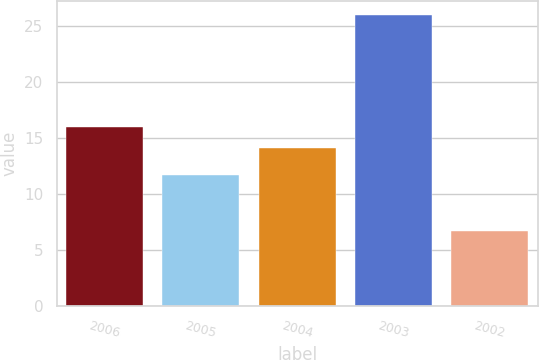<chart> <loc_0><loc_0><loc_500><loc_500><bar_chart><fcel>2006<fcel>2005<fcel>2004<fcel>2003<fcel>2002<nl><fcel>16.03<fcel>11.7<fcel>14.1<fcel>26<fcel>6.7<nl></chart> 